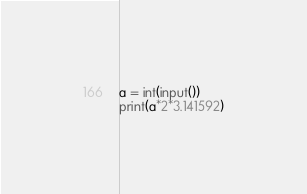Convert code to text. <code><loc_0><loc_0><loc_500><loc_500><_Python_>a = int(input())
print(a*2*3.141592)
</code> 